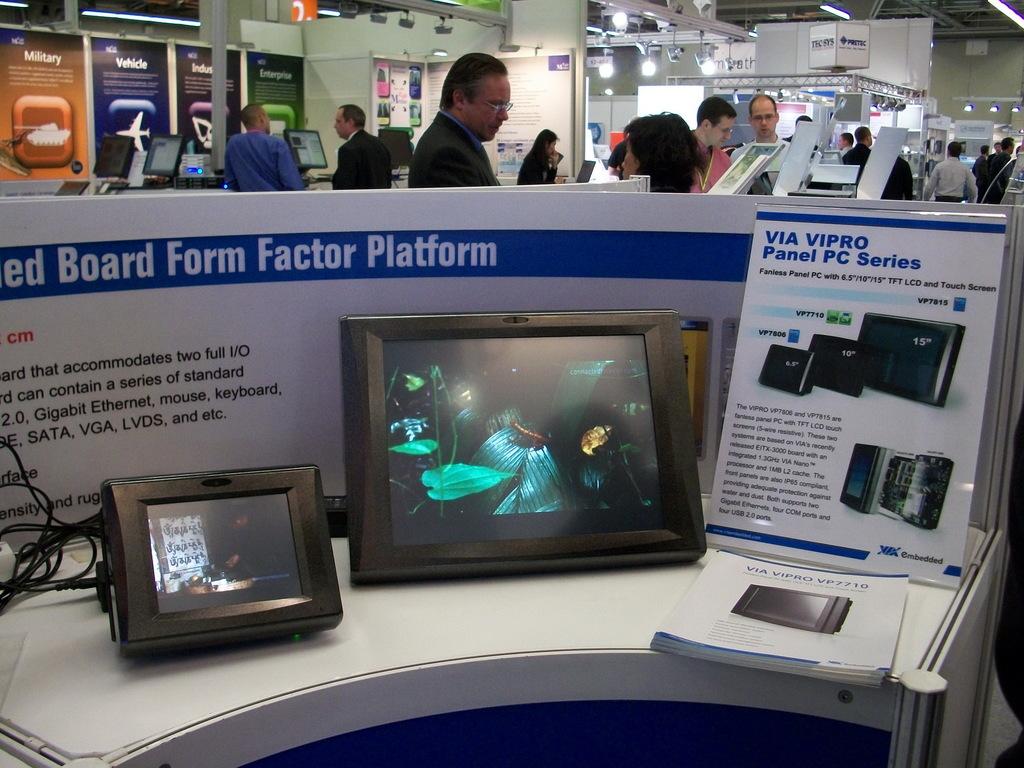What is this panel series called?
Make the answer very short. Via vipro. The red sign say stop?
Your answer should be very brief. No. 